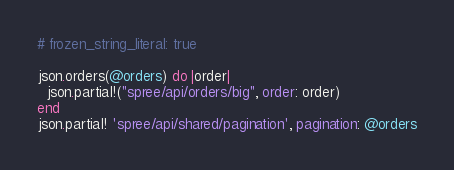Convert code to text. <code><loc_0><loc_0><loc_500><loc_500><_Ruby_># frozen_string_literal: true

json.orders(@orders) do |order|
  json.partial!("spree/api/orders/big", order: order)
end
json.partial! 'spree/api/shared/pagination', pagination: @orders
</code> 